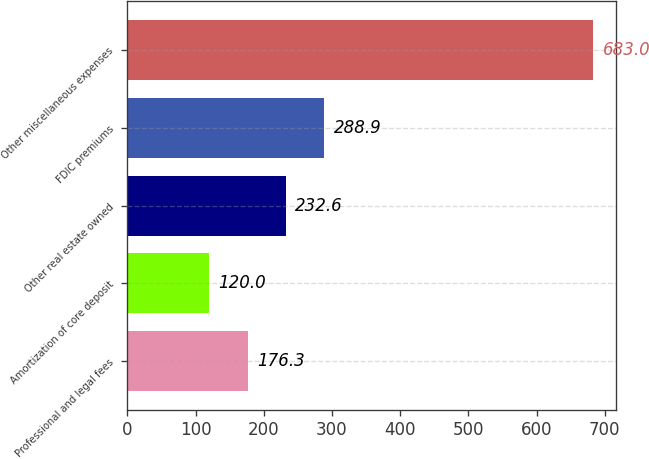Convert chart. <chart><loc_0><loc_0><loc_500><loc_500><bar_chart><fcel>Professional and legal fees<fcel>Amortization of core deposit<fcel>Other real estate owned<fcel>FDIC premiums<fcel>Other miscellaneous expenses<nl><fcel>176.3<fcel>120<fcel>232.6<fcel>288.9<fcel>683<nl></chart> 